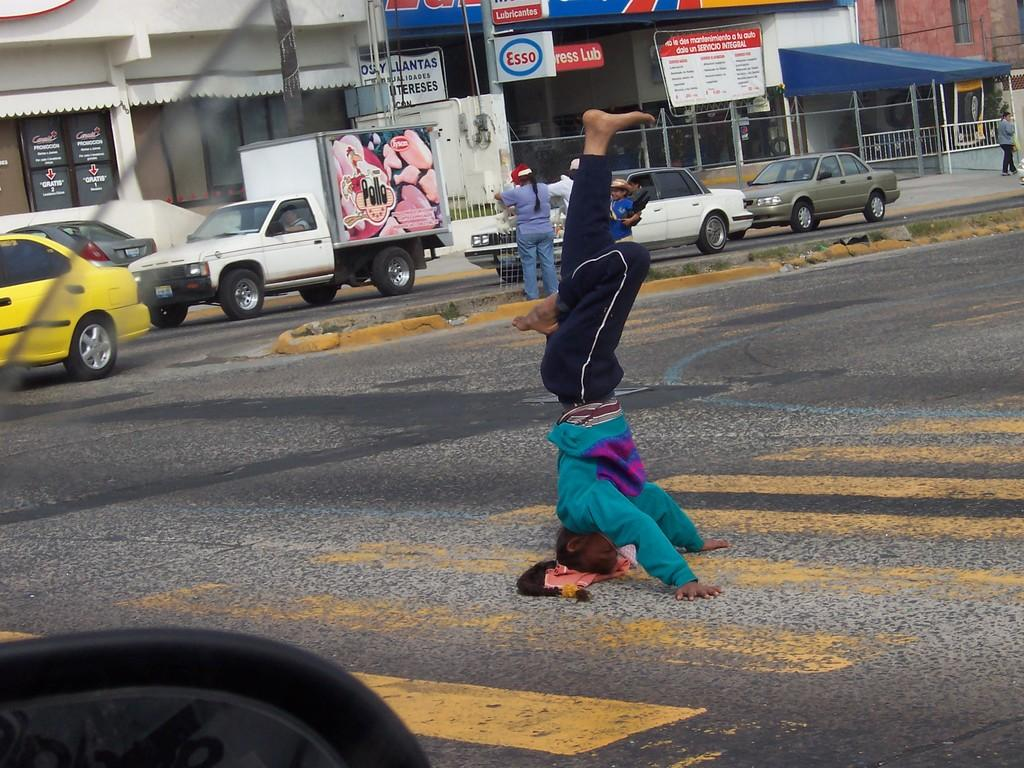<image>
Relay a brief, clear account of the picture shown. A man is standing on his head, in the middle of the road, across from an Express Lube. 